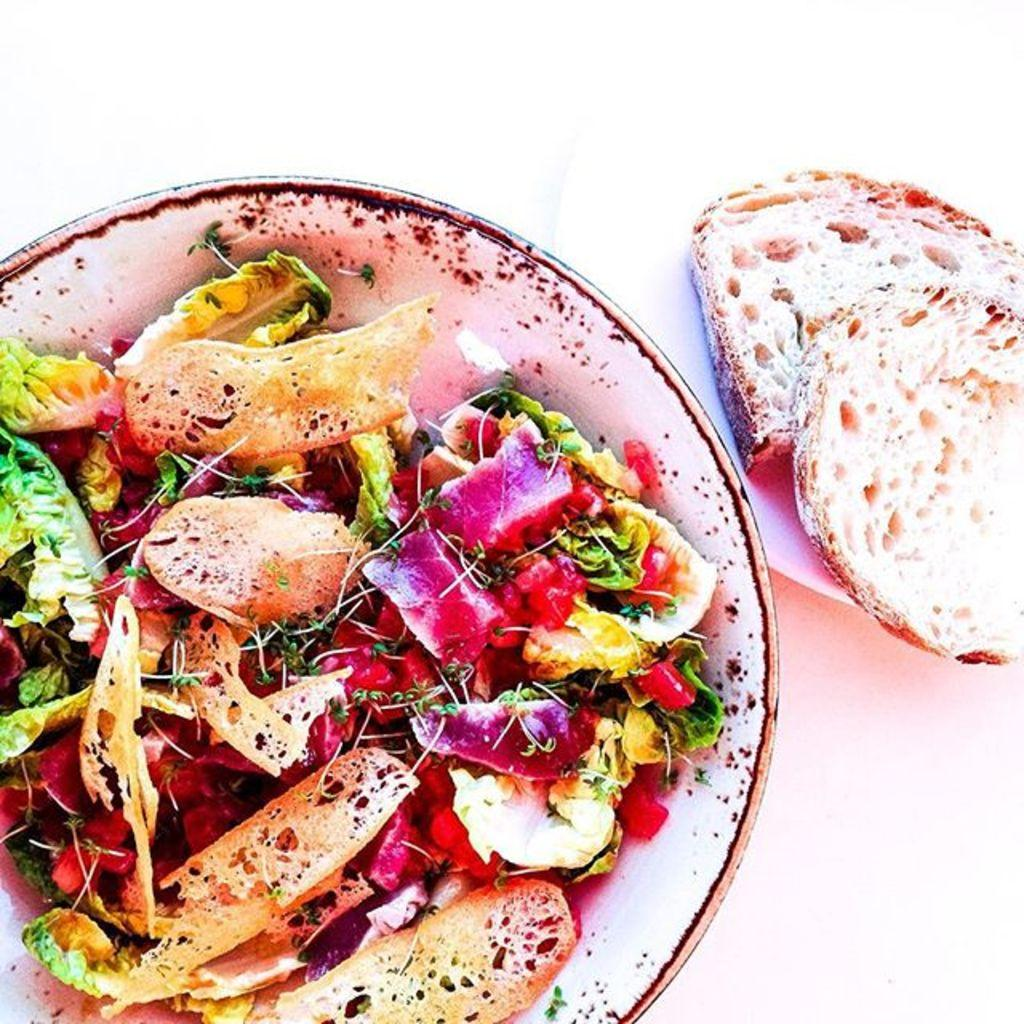What is in the bowl that is visible in the image? There are food items in the bowl. What is located beside the bowl in the image? There is a plate beside the bowl. What can be seen on the plate? There are two bread pieces on the plate. Are there any visible toes in the image? There are no visible toes in the image. Can you see any cobwebs in the image? There are no cobwebs present in the image. 